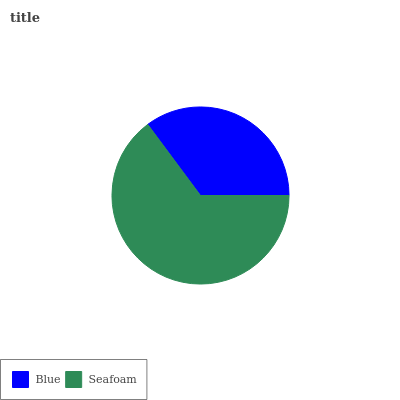Is Blue the minimum?
Answer yes or no. Yes. Is Seafoam the maximum?
Answer yes or no. Yes. Is Seafoam the minimum?
Answer yes or no. No. Is Seafoam greater than Blue?
Answer yes or no. Yes. Is Blue less than Seafoam?
Answer yes or no. Yes. Is Blue greater than Seafoam?
Answer yes or no. No. Is Seafoam less than Blue?
Answer yes or no. No. Is Seafoam the high median?
Answer yes or no. Yes. Is Blue the low median?
Answer yes or no. Yes. Is Blue the high median?
Answer yes or no. No. Is Seafoam the low median?
Answer yes or no. No. 